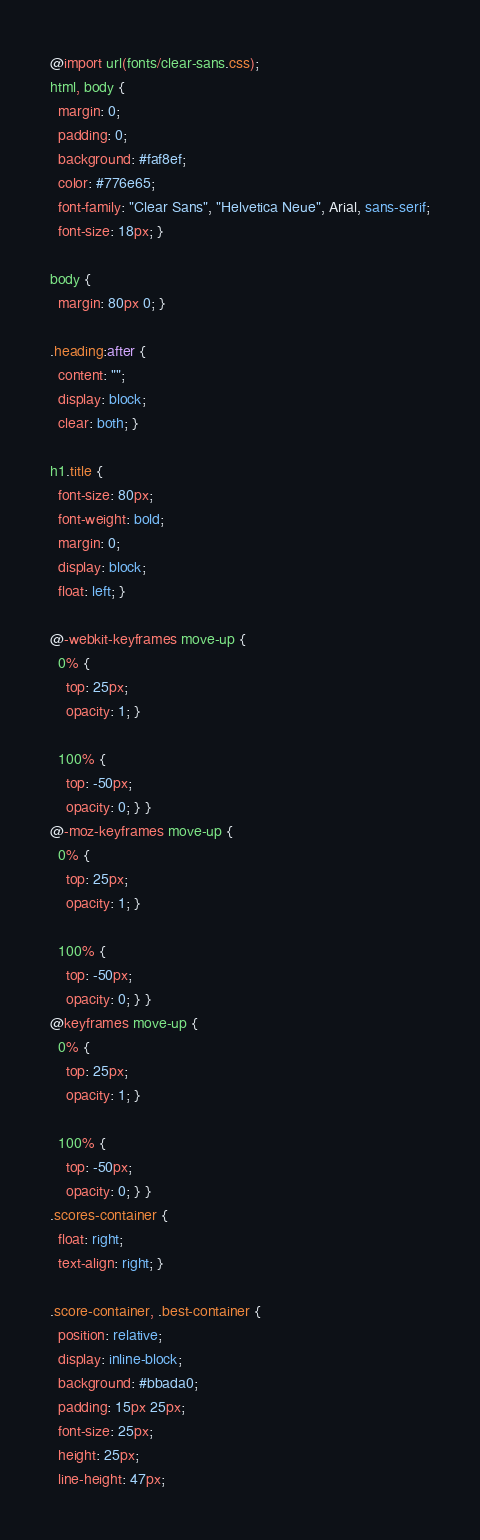<code> <loc_0><loc_0><loc_500><loc_500><_CSS_>@import url(fonts/clear-sans.css);
html, body {
  margin: 0;
  padding: 0;
  background: #faf8ef;
  color: #776e65;
  font-family: "Clear Sans", "Helvetica Neue", Arial, sans-serif;
  font-size: 18px; }

body {
  margin: 80px 0; }

.heading:after {
  content: "";
  display: block;
  clear: both; }

h1.title {
  font-size: 80px;
  font-weight: bold;
  margin: 0;
  display: block;
  float: left; }

@-webkit-keyframes move-up {
  0% {
    top: 25px;
    opacity: 1; }

  100% {
    top: -50px;
    opacity: 0; } }
@-moz-keyframes move-up {
  0% {
    top: 25px;
    opacity: 1; }

  100% {
    top: -50px;
    opacity: 0; } }
@keyframes move-up {
  0% {
    top: 25px;
    opacity: 1; }

  100% {
    top: -50px;
    opacity: 0; } }
.scores-container {
  float: right;
  text-align: right; }

.score-container, .best-container {
  position: relative;
  display: inline-block;
  background: #bbada0;
  padding: 15px 25px;
  font-size: 25px;
  height: 25px;
  line-height: 47px;</code> 